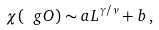<formula> <loc_0><loc_0><loc_500><loc_500>\chi ( \ g O ) \sim a L ^ { \gamma / \nu } + b \, ,</formula> 